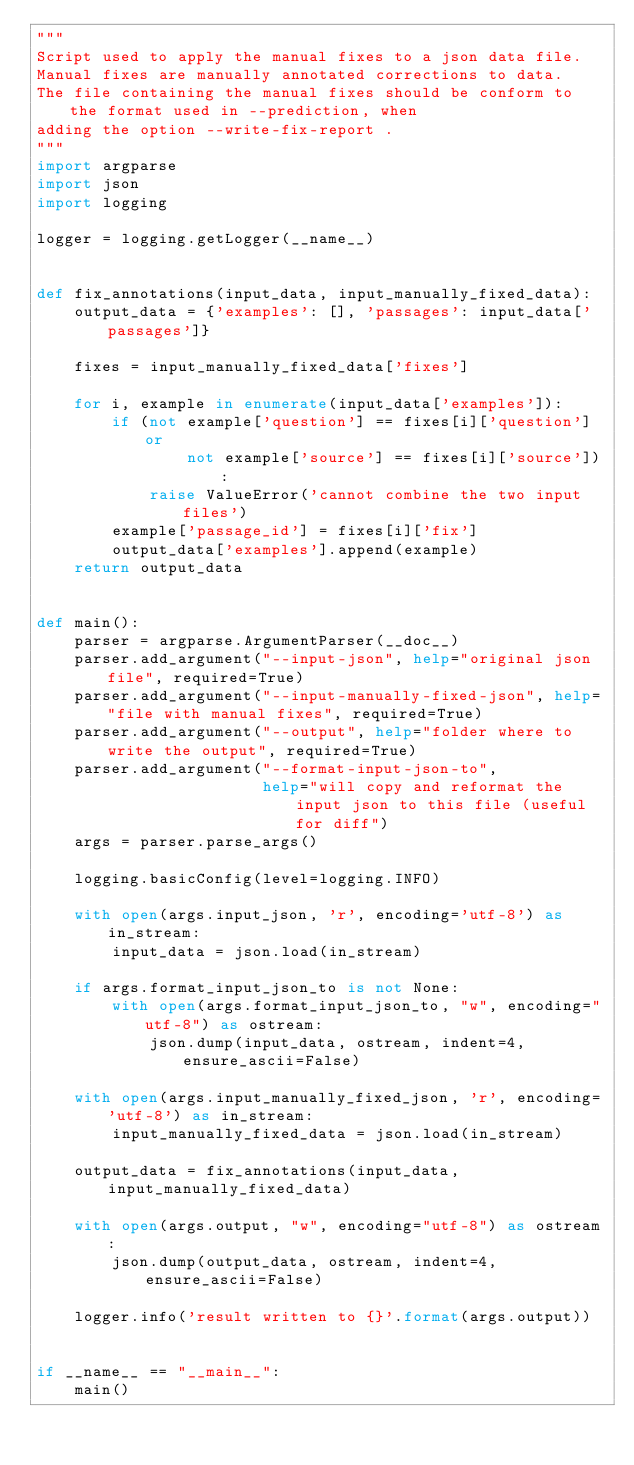Convert code to text. <code><loc_0><loc_0><loc_500><loc_500><_Python_>"""
Script used to apply the manual fixes to a json data file.
Manual fixes are manually annotated corrections to data.
The file containing the manual fixes should be conform to the format used in --prediction, when
adding the option --write-fix-report .
"""
import argparse
import json
import logging

logger = logging.getLogger(__name__)


def fix_annotations(input_data, input_manually_fixed_data):
    output_data = {'examples': [], 'passages': input_data['passages']}

    fixes = input_manually_fixed_data['fixes']

    for i, example in enumerate(input_data['examples']):
        if (not example['question'] == fixes[i]['question'] or
                not example['source'] == fixes[i]['source']):
            raise ValueError('cannot combine the two input files')
        example['passage_id'] = fixes[i]['fix']
        output_data['examples'].append(example)
    return output_data


def main():
    parser = argparse.ArgumentParser(__doc__)
    parser.add_argument("--input-json", help="original json file", required=True)
    parser.add_argument("--input-manually-fixed-json", help="file with manual fixes", required=True)
    parser.add_argument("--output", help="folder where to write the output", required=True)
    parser.add_argument("--format-input-json-to",
                        help="will copy and reformat the input json to this file (useful for diff")
    args = parser.parse_args()

    logging.basicConfig(level=logging.INFO)

    with open(args.input_json, 'r', encoding='utf-8') as in_stream:
        input_data = json.load(in_stream)

    if args.format_input_json_to is not None:
        with open(args.format_input_json_to, "w", encoding="utf-8") as ostream:
            json.dump(input_data, ostream, indent=4, ensure_ascii=False)

    with open(args.input_manually_fixed_json, 'r', encoding='utf-8') as in_stream:
        input_manually_fixed_data = json.load(in_stream)

    output_data = fix_annotations(input_data, input_manually_fixed_data)

    with open(args.output, "w", encoding="utf-8") as ostream:
        json.dump(output_data, ostream, indent=4, ensure_ascii=False)

    logger.info('result written to {}'.format(args.output))


if __name__ == "__main__":
    main()
</code> 